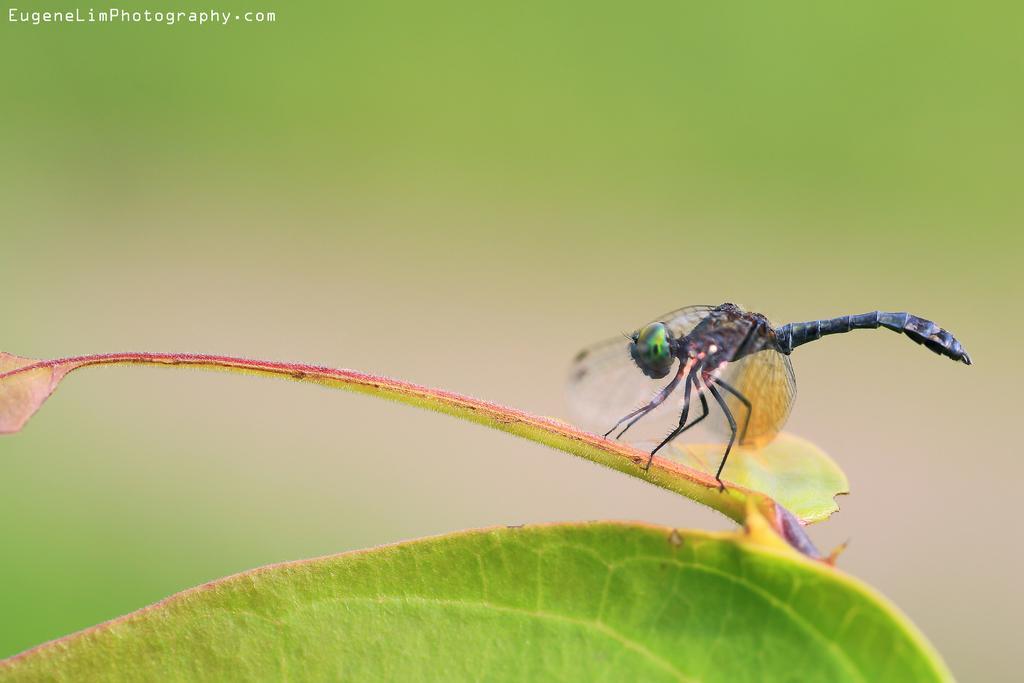Please provide a concise description of this image. In this image there is a insect that sat on a leaf, background is blur. 